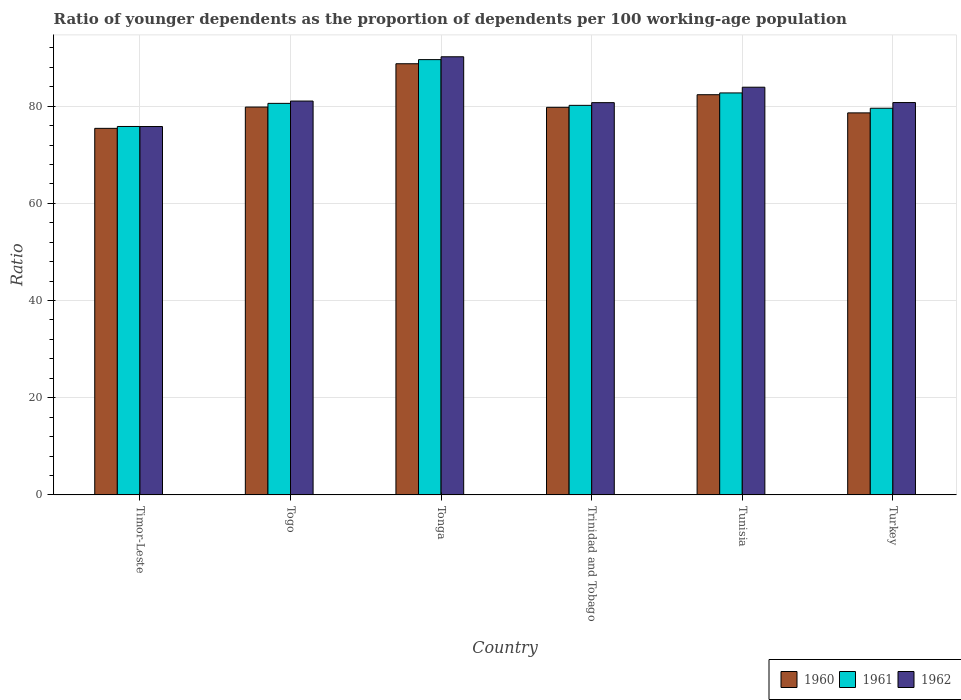How many different coloured bars are there?
Make the answer very short. 3. How many groups of bars are there?
Offer a very short reply. 6. Are the number of bars per tick equal to the number of legend labels?
Your answer should be very brief. Yes. Are the number of bars on each tick of the X-axis equal?
Give a very brief answer. Yes. How many bars are there on the 3rd tick from the right?
Provide a succinct answer. 3. What is the label of the 3rd group of bars from the left?
Make the answer very short. Tonga. In how many cases, is the number of bars for a given country not equal to the number of legend labels?
Keep it short and to the point. 0. What is the age dependency ratio(young) in 1962 in Trinidad and Tobago?
Your response must be concise. 80.72. Across all countries, what is the maximum age dependency ratio(young) in 1961?
Ensure brevity in your answer.  89.57. Across all countries, what is the minimum age dependency ratio(young) in 1960?
Make the answer very short. 75.43. In which country was the age dependency ratio(young) in 1960 maximum?
Ensure brevity in your answer.  Tonga. In which country was the age dependency ratio(young) in 1962 minimum?
Provide a short and direct response. Timor-Leste. What is the total age dependency ratio(young) in 1961 in the graph?
Make the answer very short. 488.42. What is the difference between the age dependency ratio(young) in 1960 in Togo and that in Tonga?
Give a very brief answer. -8.91. What is the difference between the age dependency ratio(young) in 1962 in Trinidad and Tobago and the age dependency ratio(young) in 1960 in Tonga?
Provide a succinct answer. -8. What is the average age dependency ratio(young) in 1962 per country?
Your answer should be compact. 82.06. What is the difference between the age dependency ratio(young) of/in 1961 and age dependency ratio(young) of/in 1960 in Togo?
Make the answer very short. 0.76. In how many countries, is the age dependency ratio(young) in 1961 greater than 60?
Offer a very short reply. 6. What is the ratio of the age dependency ratio(young) in 1960 in Timor-Leste to that in Turkey?
Provide a succinct answer. 0.96. What is the difference between the highest and the second highest age dependency ratio(young) in 1961?
Keep it short and to the point. -9. What is the difference between the highest and the lowest age dependency ratio(young) in 1962?
Offer a terse response. 14.35. In how many countries, is the age dependency ratio(young) in 1962 greater than the average age dependency ratio(young) in 1962 taken over all countries?
Your response must be concise. 2. How many countries are there in the graph?
Offer a terse response. 6. Are the values on the major ticks of Y-axis written in scientific E-notation?
Offer a very short reply. No. Does the graph contain any zero values?
Offer a very short reply. No. How many legend labels are there?
Your answer should be compact. 3. How are the legend labels stacked?
Keep it short and to the point. Horizontal. What is the title of the graph?
Offer a very short reply. Ratio of younger dependents as the proportion of dependents per 100 working-age population. What is the label or title of the X-axis?
Offer a very short reply. Country. What is the label or title of the Y-axis?
Keep it short and to the point. Ratio. What is the Ratio in 1960 in Timor-Leste?
Provide a succinct answer. 75.43. What is the Ratio in 1961 in Timor-Leste?
Your response must be concise. 75.82. What is the Ratio of 1962 in Timor-Leste?
Your answer should be very brief. 75.81. What is the Ratio of 1960 in Togo?
Provide a short and direct response. 79.81. What is the Ratio in 1961 in Togo?
Your answer should be compact. 80.57. What is the Ratio in 1962 in Togo?
Offer a very short reply. 81.05. What is the Ratio of 1960 in Tonga?
Make the answer very short. 88.73. What is the Ratio of 1961 in Tonga?
Your answer should be compact. 89.57. What is the Ratio of 1962 in Tonga?
Give a very brief answer. 90.16. What is the Ratio in 1960 in Trinidad and Tobago?
Your answer should be compact. 79.76. What is the Ratio of 1961 in Trinidad and Tobago?
Provide a short and direct response. 80.16. What is the Ratio of 1962 in Trinidad and Tobago?
Offer a terse response. 80.72. What is the Ratio of 1960 in Tunisia?
Make the answer very short. 82.35. What is the Ratio of 1961 in Tunisia?
Ensure brevity in your answer.  82.72. What is the Ratio of 1962 in Tunisia?
Your answer should be compact. 83.9. What is the Ratio of 1960 in Turkey?
Provide a short and direct response. 78.62. What is the Ratio of 1961 in Turkey?
Make the answer very short. 79.57. What is the Ratio in 1962 in Turkey?
Give a very brief answer. 80.74. Across all countries, what is the maximum Ratio of 1960?
Ensure brevity in your answer.  88.73. Across all countries, what is the maximum Ratio of 1961?
Give a very brief answer. 89.57. Across all countries, what is the maximum Ratio of 1962?
Ensure brevity in your answer.  90.16. Across all countries, what is the minimum Ratio in 1960?
Give a very brief answer. 75.43. Across all countries, what is the minimum Ratio in 1961?
Offer a terse response. 75.82. Across all countries, what is the minimum Ratio in 1962?
Make the answer very short. 75.81. What is the total Ratio of 1960 in the graph?
Provide a short and direct response. 484.7. What is the total Ratio in 1961 in the graph?
Your answer should be very brief. 488.42. What is the total Ratio in 1962 in the graph?
Offer a terse response. 492.37. What is the difference between the Ratio of 1960 in Timor-Leste and that in Togo?
Your answer should be compact. -4.38. What is the difference between the Ratio of 1961 in Timor-Leste and that in Togo?
Make the answer very short. -4.76. What is the difference between the Ratio of 1962 in Timor-Leste and that in Togo?
Your answer should be very brief. -5.24. What is the difference between the Ratio in 1960 in Timor-Leste and that in Tonga?
Provide a short and direct response. -13.3. What is the difference between the Ratio of 1961 in Timor-Leste and that in Tonga?
Make the answer very short. -13.76. What is the difference between the Ratio in 1962 in Timor-Leste and that in Tonga?
Provide a short and direct response. -14.35. What is the difference between the Ratio of 1960 in Timor-Leste and that in Trinidad and Tobago?
Offer a very short reply. -4.33. What is the difference between the Ratio of 1961 in Timor-Leste and that in Trinidad and Tobago?
Your answer should be very brief. -4.35. What is the difference between the Ratio in 1962 in Timor-Leste and that in Trinidad and Tobago?
Your answer should be very brief. -4.91. What is the difference between the Ratio in 1960 in Timor-Leste and that in Tunisia?
Your response must be concise. -6.92. What is the difference between the Ratio of 1961 in Timor-Leste and that in Tunisia?
Keep it short and to the point. -6.91. What is the difference between the Ratio of 1962 in Timor-Leste and that in Tunisia?
Your answer should be compact. -8.09. What is the difference between the Ratio in 1960 in Timor-Leste and that in Turkey?
Provide a succinct answer. -3.18. What is the difference between the Ratio of 1961 in Timor-Leste and that in Turkey?
Provide a succinct answer. -3.75. What is the difference between the Ratio of 1962 in Timor-Leste and that in Turkey?
Provide a short and direct response. -4.93. What is the difference between the Ratio of 1960 in Togo and that in Tonga?
Keep it short and to the point. -8.91. What is the difference between the Ratio of 1961 in Togo and that in Tonga?
Keep it short and to the point. -9. What is the difference between the Ratio of 1962 in Togo and that in Tonga?
Offer a terse response. -9.11. What is the difference between the Ratio in 1960 in Togo and that in Trinidad and Tobago?
Ensure brevity in your answer.  0.05. What is the difference between the Ratio of 1961 in Togo and that in Trinidad and Tobago?
Provide a short and direct response. 0.41. What is the difference between the Ratio of 1962 in Togo and that in Trinidad and Tobago?
Provide a short and direct response. 0.33. What is the difference between the Ratio of 1960 in Togo and that in Tunisia?
Offer a terse response. -2.54. What is the difference between the Ratio of 1961 in Togo and that in Tunisia?
Provide a succinct answer. -2.15. What is the difference between the Ratio in 1962 in Togo and that in Tunisia?
Keep it short and to the point. -2.85. What is the difference between the Ratio of 1960 in Togo and that in Turkey?
Your answer should be very brief. 1.2. What is the difference between the Ratio in 1962 in Togo and that in Turkey?
Your response must be concise. 0.31. What is the difference between the Ratio of 1960 in Tonga and that in Trinidad and Tobago?
Offer a terse response. 8.97. What is the difference between the Ratio in 1961 in Tonga and that in Trinidad and Tobago?
Provide a succinct answer. 9.41. What is the difference between the Ratio of 1962 in Tonga and that in Trinidad and Tobago?
Keep it short and to the point. 9.44. What is the difference between the Ratio in 1960 in Tonga and that in Tunisia?
Your answer should be compact. 6.37. What is the difference between the Ratio of 1961 in Tonga and that in Tunisia?
Your answer should be compact. 6.85. What is the difference between the Ratio of 1962 in Tonga and that in Tunisia?
Provide a succinct answer. 6.26. What is the difference between the Ratio in 1960 in Tonga and that in Turkey?
Your answer should be compact. 10.11. What is the difference between the Ratio in 1961 in Tonga and that in Turkey?
Offer a very short reply. 10.01. What is the difference between the Ratio of 1962 in Tonga and that in Turkey?
Your answer should be very brief. 9.42. What is the difference between the Ratio in 1960 in Trinidad and Tobago and that in Tunisia?
Offer a very short reply. -2.59. What is the difference between the Ratio of 1961 in Trinidad and Tobago and that in Tunisia?
Your answer should be compact. -2.56. What is the difference between the Ratio of 1962 in Trinidad and Tobago and that in Tunisia?
Make the answer very short. -3.17. What is the difference between the Ratio in 1960 in Trinidad and Tobago and that in Turkey?
Your answer should be compact. 1.14. What is the difference between the Ratio of 1961 in Trinidad and Tobago and that in Turkey?
Ensure brevity in your answer.  0.59. What is the difference between the Ratio in 1962 in Trinidad and Tobago and that in Turkey?
Your answer should be very brief. -0.02. What is the difference between the Ratio in 1960 in Tunisia and that in Turkey?
Provide a short and direct response. 3.74. What is the difference between the Ratio in 1961 in Tunisia and that in Turkey?
Ensure brevity in your answer.  3.15. What is the difference between the Ratio of 1962 in Tunisia and that in Turkey?
Provide a short and direct response. 3.16. What is the difference between the Ratio in 1960 in Timor-Leste and the Ratio in 1961 in Togo?
Make the answer very short. -5.14. What is the difference between the Ratio in 1960 in Timor-Leste and the Ratio in 1962 in Togo?
Your response must be concise. -5.62. What is the difference between the Ratio in 1961 in Timor-Leste and the Ratio in 1962 in Togo?
Keep it short and to the point. -5.23. What is the difference between the Ratio of 1960 in Timor-Leste and the Ratio of 1961 in Tonga?
Your answer should be very brief. -14.14. What is the difference between the Ratio of 1960 in Timor-Leste and the Ratio of 1962 in Tonga?
Your answer should be compact. -14.73. What is the difference between the Ratio of 1961 in Timor-Leste and the Ratio of 1962 in Tonga?
Offer a terse response. -14.34. What is the difference between the Ratio in 1960 in Timor-Leste and the Ratio in 1961 in Trinidad and Tobago?
Ensure brevity in your answer.  -4.73. What is the difference between the Ratio in 1960 in Timor-Leste and the Ratio in 1962 in Trinidad and Tobago?
Ensure brevity in your answer.  -5.29. What is the difference between the Ratio of 1961 in Timor-Leste and the Ratio of 1962 in Trinidad and Tobago?
Your answer should be compact. -4.91. What is the difference between the Ratio in 1960 in Timor-Leste and the Ratio in 1961 in Tunisia?
Make the answer very short. -7.29. What is the difference between the Ratio in 1960 in Timor-Leste and the Ratio in 1962 in Tunisia?
Make the answer very short. -8.46. What is the difference between the Ratio in 1961 in Timor-Leste and the Ratio in 1962 in Tunisia?
Give a very brief answer. -8.08. What is the difference between the Ratio of 1960 in Timor-Leste and the Ratio of 1961 in Turkey?
Ensure brevity in your answer.  -4.14. What is the difference between the Ratio of 1960 in Timor-Leste and the Ratio of 1962 in Turkey?
Ensure brevity in your answer.  -5.31. What is the difference between the Ratio in 1961 in Timor-Leste and the Ratio in 1962 in Turkey?
Offer a terse response. -4.92. What is the difference between the Ratio in 1960 in Togo and the Ratio in 1961 in Tonga?
Give a very brief answer. -9.76. What is the difference between the Ratio in 1960 in Togo and the Ratio in 1962 in Tonga?
Make the answer very short. -10.35. What is the difference between the Ratio in 1961 in Togo and the Ratio in 1962 in Tonga?
Your answer should be very brief. -9.59. What is the difference between the Ratio in 1960 in Togo and the Ratio in 1961 in Trinidad and Tobago?
Provide a short and direct response. -0.35. What is the difference between the Ratio of 1960 in Togo and the Ratio of 1962 in Trinidad and Tobago?
Give a very brief answer. -0.91. What is the difference between the Ratio of 1961 in Togo and the Ratio of 1962 in Trinidad and Tobago?
Your answer should be compact. -0.15. What is the difference between the Ratio of 1960 in Togo and the Ratio of 1961 in Tunisia?
Your answer should be very brief. -2.91. What is the difference between the Ratio in 1960 in Togo and the Ratio in 1962 in Tunisia?
Keep it short and to the point. -4.08. What is the difference between the Ratio in 1961 in Togo and the Ratio in 1962 in Tunisia?
Ensure brevity in your answer.  -3.32. What is the difference between the Ratio of 1960 in Togo and the Ratio of 1961 in Turkey?
Offer a very short reply. 0.24. What is the difference between the Ratio in 1960 in Togo and the Ratio in 1962 in Turkey?
Offer a very short reply. -0.93. What is the difference between the Ratio of 1961 in Togo and the Ratio of 1962 in Turkey?
Your answer should be compact. -0.17. What is the difference between the Ratio of 1960 in Tonga and the Ratio of 1961 in Trinidad and Tobago?
Make the answer very short. 8.56. What is the difference between the Ratio of 1960 in Tonga and the Ratio of 1962 in Trinidad and Tobago?
Make the answer very short. 8. What is the difference between the Ratio in 1961 in Tonga and the Ratio in 1962 in Trinidad and Tobago?
Your answer should be very brief. 8.85. What is the difference between the Ratio in 1960 in Tonga and the Ratio in 1961 in Tunisia?
Offer a very short reply. 6. What is the difference between the Ratio in 1960 in Tonga and the Ratio in 1962 in Tunisia?
Provide a succinct answer. 4.83. What is the difference between the Ratio in 1961 in Tonga and the Ratio in 1962 in Tunisia?
Offer a very short reply. 5.68. What is the difference between the Ratio of 1960 in Tonga and the Ratio of 1961 in Turkey?
Give a very brief answer. 9.16. What is the difference between the Ratio in 1960 in Tonga and the Ratio in 1962 in Turkey?
Give a very brief answer. 7.99. What is the difference between the Ratio of 1961 in Tonga and the Ratio of 1962 in Turkey?
Offer a terse response. 8.84. What is the difference between the Ratio of 1960 in Trinidad and Tobago and the Ratio of 1961 in Tunisia?
Your answer should be compact. -2.96. What is the difference between the Ratio of 1960 in Trinidad and Tobago and the Ratio of 1962 in Tunisia?
Make the answer very short. -4.14. What is the difference between the Ratio of 1961 in Trinidad and Tobago and the Ratio of 1962 in Tunisia?
Your answer should be compact. -3.73. What is the difference between the Ratio in 1960 in Trinidad and Tobago and the Ratio in 1961 in Turkey?
Keep it short and to the point. 0.19. What is the difference between the Ratio in 1960 in Trinidad and Tobago and the Ratio in 1962 in Turkey?
Give a very brief answer. -0.98. What is the difference between the Ratio of 1961 in Trinidad and Tobago and the Ratio of 1962 in Turkey?
Give a very brief answer. -0.58. What is the difference between the Ratio of 1960 in Tunisia and the Ratio of 1961 in Turkey?
Ensure brevity in your answer.  2.78. What is the difference between the Ratio of 1960 in Tunisia and the Ratio of 1962 in Turkey?
Your response must be concise. 1.61. What is the difference between the Ratio in 1961 in Tunisia and the Ratio in 1962 in Turkey?
Keep it short and to the point. 1.98. What is the average Ratio of 1960 per country?
Give a very brief answer. 80.78. What is the average Ratio of 1961 per country?
Your answer should be very brief. 81.4. What is the average Ratio of 1962 per country?
Your answer should be compact. 82.06. What is the difference between the Ratio in 1960 and Ratio in 1961 in Timor-Leste?
Your answer should be compact. -0.39. What is the difference between the Ratio in 1960 and Ratio in 1962 in Timor-Leste?
Offer a very short reply. -0.38. What is the difference between the Ratio in 1961 and Ratio in 1962 in Timor-Leste?
Make the answer very short. 0.01. What is the difference between the Ratio of 1960 and Ratio of 1961 in Togo?
Offer a terse response. -0.76. What is the difference between the Ratio in 1960 and Ratio in 1962 in Togo?
Offer a very short reply. -1.24. What is the difference between the Ratio in 1961 and Ratio in 1962 in Togo?
Offer a very short reply. -0.47. What is the difference between the Ratio of 1960 and Ratio of 1961 in Tonga?
Your response must be concise. -0.85. What is the difference between the Ratio in 1960 and Ratio in 1962 in Tonga?
Offer a very short reply. -1.43. What is the difference between the Ratio of 1961 and Ratio of 1962 in Tonga?
Offer a very short reply. -0.58. What is the difference between the Ratio of 1960 and Ratio of 1961 in Trinidad and Tobago?
Ensure brevity in your answer.  -0.4. What is the difference between the Ratio in 1960 and Ratio in 1962 in Trinidad and Tobago?
Offer a very short reply. -0.96. What is the difference between the Ratio in 1961 and Ratio in 1962 in Trinidad and Tobago?
Make the answer very short. -0.56. What is the difference between the Ratio of 1960 and Ratio of 1961 in Tunisia?
Your response must be concise. -0.37. What is the difference between the Ratio in 1960 and Ratio in 1962 in Tunisia?
Keep it short and to the point. -1.54. What is the difference between the Ratio of 1961 and Ratio of 1962 in Tunisia?
Your answer should be very brief. -1.17. What is the difference between the Ratio of 1960 and Ratio of 1961 in Turkey?
Provide a short and direct response. -0.95. What is the difference between the Ratio in 1960 and Ratio in 1962 in Turkey?
Your response must be concise. -2.12. What is the difference between the Ratio of 1961 and Ratio of 1962 in Turkey?
Give a very brief answer. -1.17. What is the ratio of the Ratio of 1960 in Timor-Leste to that in Togo?
Give a very brief answer. 0.95. What is the ratio of the Ratio of 1961 in Timor-Leste to that in Togo?
Your answer should be very brief. 0.94. What is the ratio of the Ratio in 1962 in Timor-Leste to that in Togo?
Your answer should be compact. 0.94. What is the ratio of the Ratio of 1960 in Timor-Leste to that in Tonga?
Ensure brevity in your answer.  0.85. What is the ratio of the Ratio in 1961 in Timor-Leste to that in Tonga?
Offer a terse response. 0.85. What is the ratio of the Ratio in 1962 in Timor-Leste to that in Tonga?
Give a very brief answer. 0.84. What is the ratio of the Ratio in 1960 in Timor-Leste to that in Trinidad and Tobago?
Your answer should be very brief. 0.95. What is the ratio of the Ratio of 1961 in Timor-Leste to that in Trinidad and Tobago?
Make the answer very short. 0.95. What is the ratio of the Ratio of 1962 in Timor-Leste to that in Trinidad and Tobago?
Your response must be concise. 0.94. What is the ratio of the Ratio in 1960 in Timor-Leste to that in Tunisia?
Provide a short and direct response. 0.92. What is the ratio of the Ratio of 1961 in Timor-Leste to that in Tunisia?
Your answer should be very brief. 0.92. What is the ratio of the Ratio of 1962 in Timor-Leste to that in Tunisia?
Keep it short and to the point. 0.9. What is the ratio of the Ratio in 1960 in Timor-Leste to that in Turkey?
Your answer should be compact. 0.96. What is the ratio of the Ratio in 1961 in Timor-Leste to that in Turkey?
Ensure brevity in your answer.  0.95. What is the ratio of the Ratio of 1962 in Timor-Leste to that in Turkey?
Offer a very short reply. 0.94. What is the ratio of the Ratio in 1960 in Togo to that in Tonga?
Ensure brevity in your answer.  0.9. What is the ratio of the Ratio in 1961 in Togo to that in Tonga?
Offer a very short reply. 0.9. What is the ratio of the Ratio in 1962 in Togo to that in Tonga?
Ensure brevity in your answer.  0.9. What is the ratio of the Ratio in 1960 in Togo to that in Trinidad and Tobago?
Your response must be concise. 1. What is the ratio of the Ratio in 1961 in Togo to that in Trinidad and Tobago?
Offer a very short reply. 1.01. What is the ratio of the Ratio of 1962 in Togo to that in Trinidad and Tobago?
Give a very brief answer. 1. What is the ratio of the Ratio of 1960 in Togo to that in Tunisia?
Your answer should be compact. 0.97. What is the ratio of the Ratio in 1960 in Togo to that in Turkey?
Keep it short and to the point. 1.02. What is the ratio of the Ratio of 1961 in Togo to that in Turkey?
Offer a terse response. 1.01. What is the ratio of the Ratio in 1962 in Togo to that in Turkey?
Offer a very short reply. 1. What is the ratio of the Ratio of 1960 in Tonga to that in Trinidad and Tobago?
Make the answer very short. 1.11. What is the ratio of the Ratio of 1961 in Tonga to that in Trinidad and Tobago?
Make the answer very short. 1.12. What is the ratio of the Ratio of 1962 in Tonga to that in Trinidad and Tobago?
Provide a short and direct response. 1.12. What is the ratio of the Ratio of 1960 in Tonga to that in Tunisia?
Your answer should be compact. 1.08. What is the ratio of the Ratio in 1961 in Tonga to that in Tunisia?
Give a very brief answer. 1.08. What is the ratio of the Ratio of 1962 in Tonga to that in Tunisia?
Make the answer very short. 1.07. What is the ratio of the Ratio of 1960 in Tonga to that in Turkey?
Your answer should be very brief. 1.13. What is the ratio of the Ratio in 1961 in Tonga to that in Turkey?
Your answer should be compact. 1.13. What is the ratio of the Ratio in 1962 in Tonga to that in Turkey?
Ensure brevity in your answer.  1.12. What is the ratio of the Ratio in 1960 in Trinidad and Tobago to that in Tunisia?
Provide a succinct answer. 0.97. What is the ratio of the Ratio in 1961 in Trinidad and Tobago to that in Tunisia?
Your answer should be very brief. 0.97. What is the ratio of the Ratio of 1962 in Trinidad and Tobago to that in Tunisia?
Offer a terse response. 0.96. What is the ratio of the Ratio in 1960 in Trinidad and Tobago to that in Turkey?
Give a very brief answer. 1.01. What is the ratio of the Ratio in 1961 in Trinidad and Tobago to that in Turkey?
Your response must be concise. 1.01. What is the ratio of the Ratio in 1960 in Tunisia to that in Turkey?
Offer a terse response. 1.05. What is the ratio of the Ratio of 1961 in Tunisia to that in Turkey?
Ensure brevity in your answer.  1.04. What is the ratio of the Ratio in 1962 in Tunisia to that in Turkey?
Give a very brief answer. 1.04. What is the difference between the highest and the second highest Ratio in 1960?
Provide a succinct answer. 6.37. What is the difference between the highest and the second highest Ratio of 1961?
Offer a terse response. 6.85. What is the difference between the highest and the second highest Ratio in 1962?
Provide a succinct answer. 6.26. What is the difference between the highest and the lowest Ratio of 1960?
Offer a terse response. 13.3. What is the difference between the highest and the lowest Ratio of 1961?
Give a very brief answer. 13.76. What is the difference between the highest and the lowest Ratio in 1962?
Ensure brevity in your answer.  14.35. 